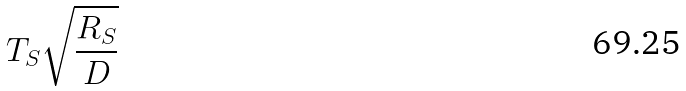Convert formula to latex. <formula><loc_0><loc_0><loc_500><loc_500>T _ { S } \sqrt { \frac { R _ { S } } { D } }</formula> 